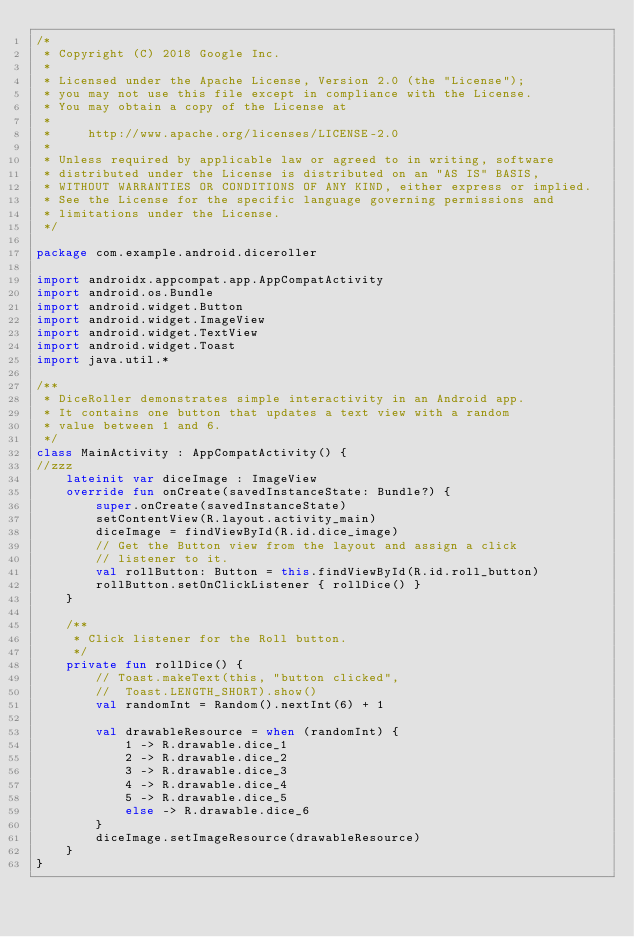<code> <loc_0><loc_0><loc_500><loc_500><_Kotlin_>/*
 * Copyright (C) 2018 Google Inc.
 *
 * Licensed under the Apache License, Version 2.0 (the "License");
 * you may not use this file except in compliance with the License.
 * You may obtain a copy of the License at
 *
 *     http://www.apache.org/licenses/LICENSE-2.0
 *
 * Unless required by applicable law or agreed to in writing, software
 * distributed under the License is distributed on an "AS IS" BASIS,
 * WITHOUT WARRANTIES OR CONDITIONS OF ANY KIND, either express or implied.
 * See the License for the specific language governing permissions and
 * limitations under the License.
 */

package com.example.android.diceroller

import androidx.appcompat.app.AppCompatActivity
import android.os.Bundle
import android.widget.Button
import android.widget.ImageView
import android.widget.TextView
import android.widget.Toast
import java.util.*

/**
 * DiceRoller demonstrates simple interactivity in an Android app.
 * It contains one button that updates a text view with a random
 * value between 1 and 6.
 */
class MainActivity : AppCompatActivity() {
//zzz
    lateinit var diceImage : ImageView
    override fun onCreate(savedInstanceState: Bundle?) {
        super.onCreate(savedInstanceState)
        setContentView(R.layout.activity_main)
        diceImage = findViewById(R.id.dice_image)
        // Get the Button view from the layout and assign a click
        // listener to it.
        val rollButton: Button = this.findViewById(R.id.roll_button)
        rollButton.setOnClickListener { rollDice() }
    }

    /**
     * Click listener for the Roll button.
     */
    private fun rollDice() {
        // Toast.makeText(this, "button clicked",
        //  Toast.LENGTH_SHORT).show()
        val randomInt = Random().nextInt(6) + 1

        val drawableResource = when (randomInt) {
            1 -> R.drawable.dice_1
            2 -> R.drawable.dice_2
            3 -> R.drawable.dice_3
            4 -> R.drawable.dice_4
            5 -> R.drawable.dice_5
            else -> R.drawable.dice_6
        }
        diceImage.setImageResource(drawableResource)
    }
}
</code> 